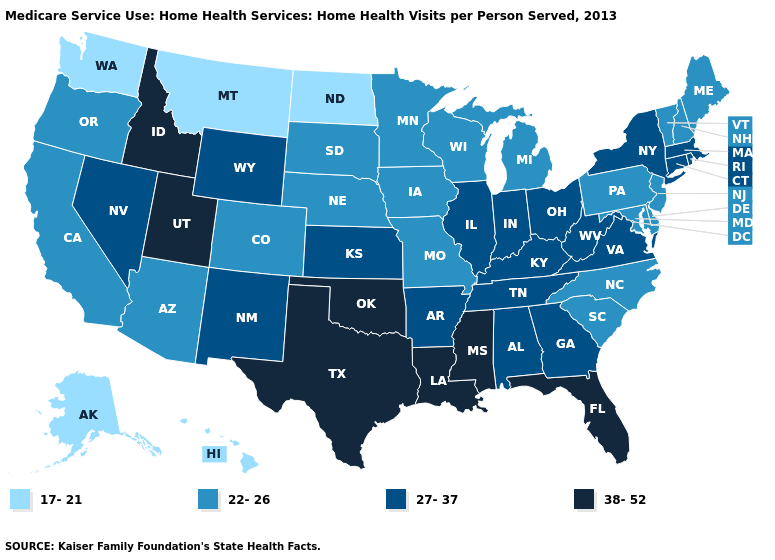What is the value of Michigan?
Give a very brief answer. 22-26. Does North Dakota have the lowest value in the MidWest?
Concise answer only. Yes. Among the states that border Mississippi , which have the highest value?
Be succinct. Louisiana. What is the value of New Hampshire?
Be succinct. 22-26. What is the value of Utah?
Quick response, please. 38-52. Which states hav the highest value in the West?
Write a very short answer. Idaho, Utah. Does Arkansas have a lower value than Louisiana?
Write a very short answer. Yes. What is the value of Oregon?
Quick response, please. 22-26. Name the states that have a value in the range 17-21?
Short answer required. Alaska, Hawaii, Montana, North Dakota, Washington. Does Pennsylvania have the highest value in the Northeast?
Give a very brief answer. No. What is the highest value in the USA?
Quick response, please. 38-52. Is the legend a continuous bar?
Write a very short answer. No. What is the value of California?
Quick response, please. 22-26. What is the highest value in the Northeast ?
Be succinct. 27-37. What is the highest value in the USA?
Give a very brief answer. 38-52. 